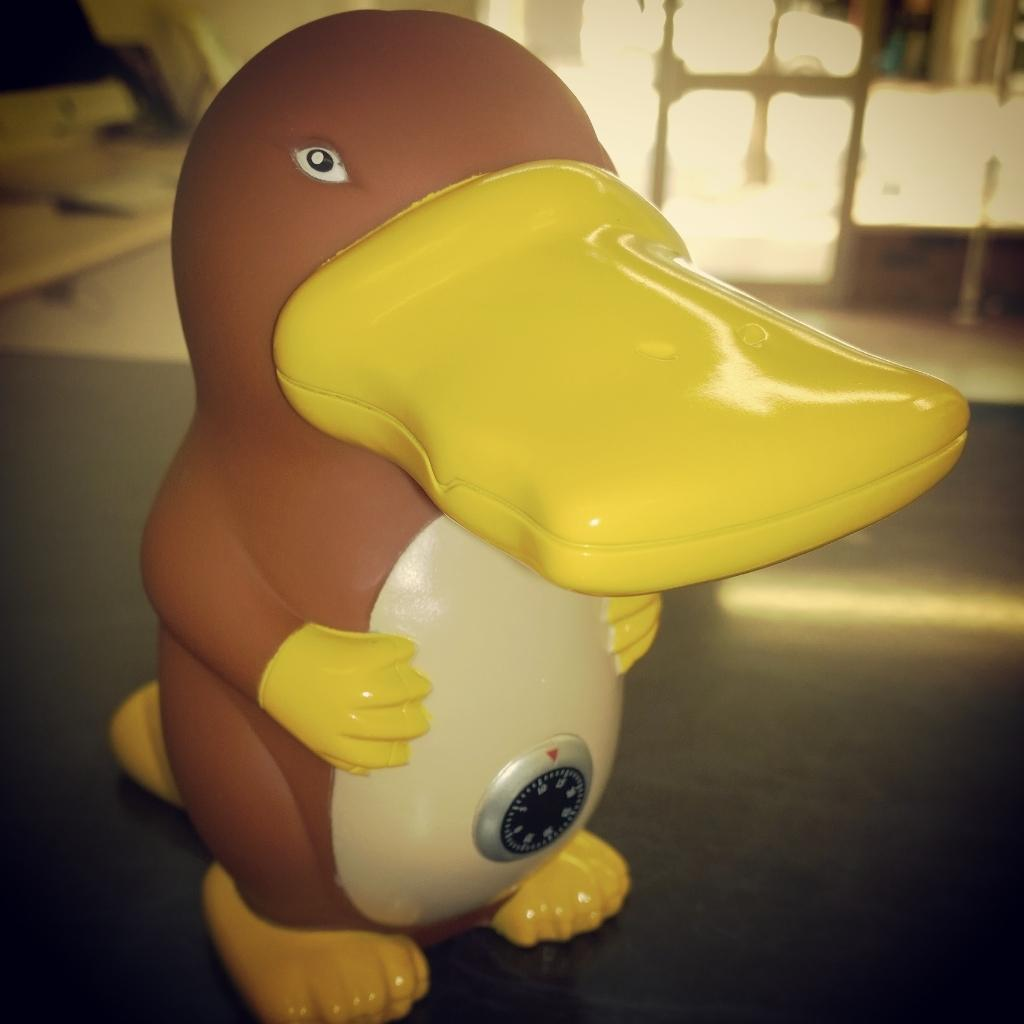What is the main subject in the center of the image? There is a toy in the center of the image. Can you describe the appearance of the toy? The toy is yellow and brown in color. What can be seen in the background of the image? There is a wall, a door, a table, and other objects in the background of the image. How does the toy rub against the wall in the image? The toy does not rub against the wall in the image; it is stationary in the center of the image. What type of bucket is present in the image? There is no bucket present in the image. 